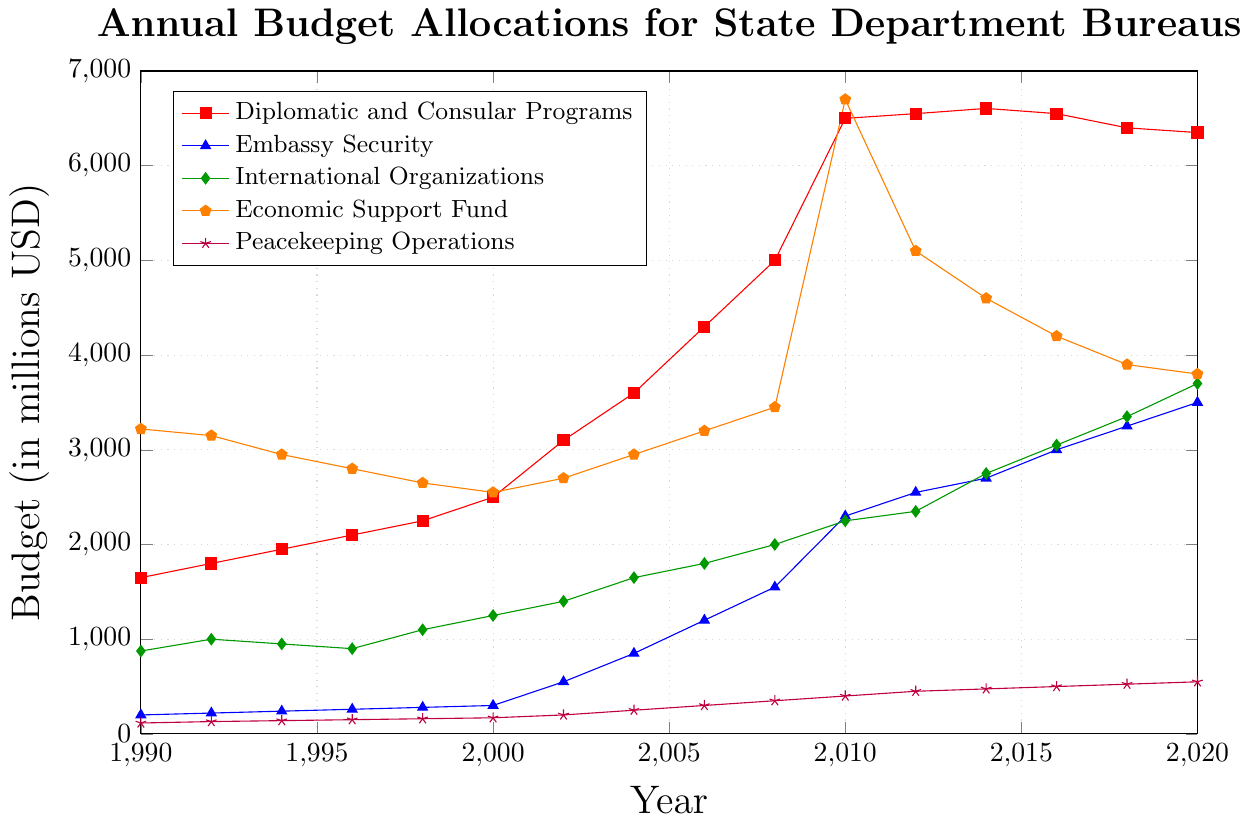Which bureau had the highest budget in 2020? From the plot, observe the endpoints (2020) of each line. The Economic Support Fund line reaches the highest point.
Answer: Economic Support Fund How much did the budget for Peacekeeping Operations increase from 1990 to 2020? Find the budget values for Peacekeeping Operations in 1990 and 2020 from the line. Subtract the earlier value (115) from the later value (550), so the increase is 550 - 115.
Answer: 435 Which two bureaus had almost equal budgets in 2010, and what were their values? Locate the 2010 point for each bureau. The lines for International Organizations and Economic Support Fund intersect close to the same value. Both budgets are around 2250 and 6700, respectively.
Answer: International Organizations and Economic Support Fund at around 2250 and 6700 What was the trend for the Embassy Security budget between 2000 and 2010? Look at the line for Embassy Security between the years 2000 and 2010; the line shows a steady upward trend, moving from 300 to 2300.
Answer: Increasing How does the 2018 budget for Diplomatic and Consular Programs compare to its budget in 1998? Find the budget values for Diplomatic and Consular Programs in 2018 and 1998. Compare 6400 (2018) to 2250 (1998).
Answer: 2018 budget is much higher What is the average budget for International Organizations over the years 1990, 2000, 2010, and 2020? Take the budget values for International Organizations in 1990 (875), 2000 (1250), 2010 (2250), and 2020 (3700). Calculate the average: (875 + 1250 + 2250 + 3700) / 4.
Answer: 2019 Which bureau experienced the largest growth in budget from 2000 to 2008? Subtract the 2000 values from the 2008 values for each bureau and compare the differences. The Economic Support Fund grew the most, from 2550 to 3450, with a difference of 3450 - 2550 = 900.
Answer: Economic Support Fund What was the budget for Diplomatic and Consular Programs in 2002, and how does it compare to the same bureau's budget in 2016? Find the values from the graph: Diplomatic and Consular Programs had a budget of 3100 in 2002 and 6550 in 2016.
Answer: 2016 budget is more than double By how much did the budget for Peacekeeping Operations increase between 2002 and 2012? Subtract the budget value of Peacekeeping Operations in 2002 from the value in 2012. The difference is 450 (2012) - 200 (2002).
Answer: 250 